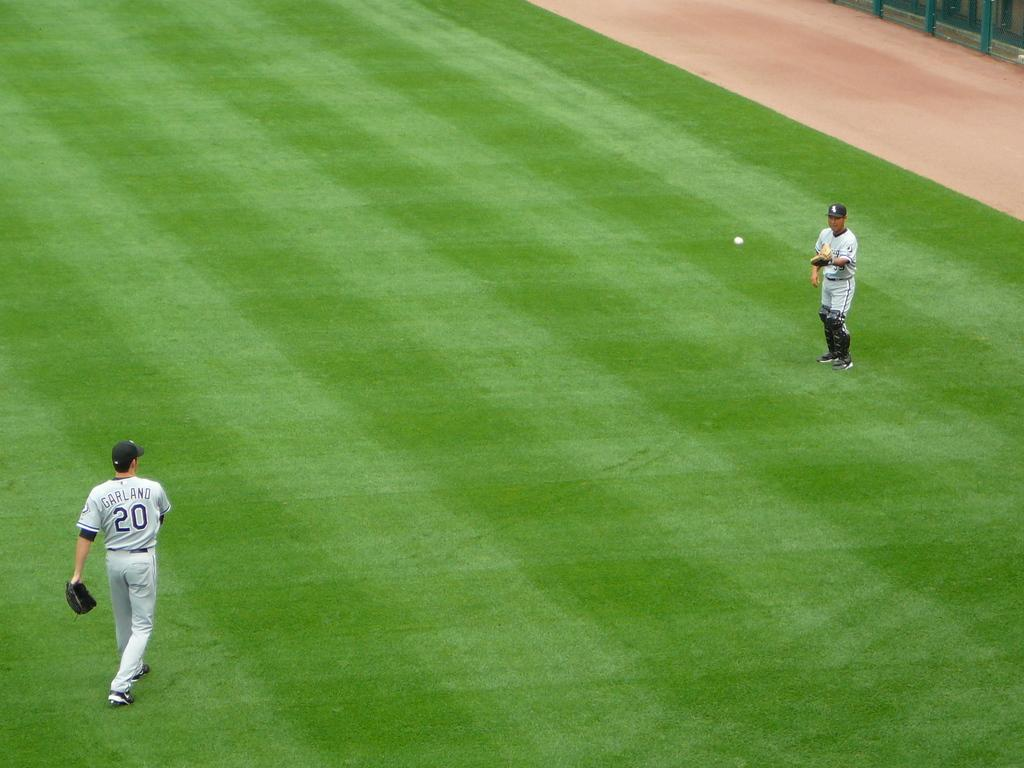<image>
Create a compact narrative representing the image presented. A baseball player named Garland throws the ball to the pitcher with the shin guard. 